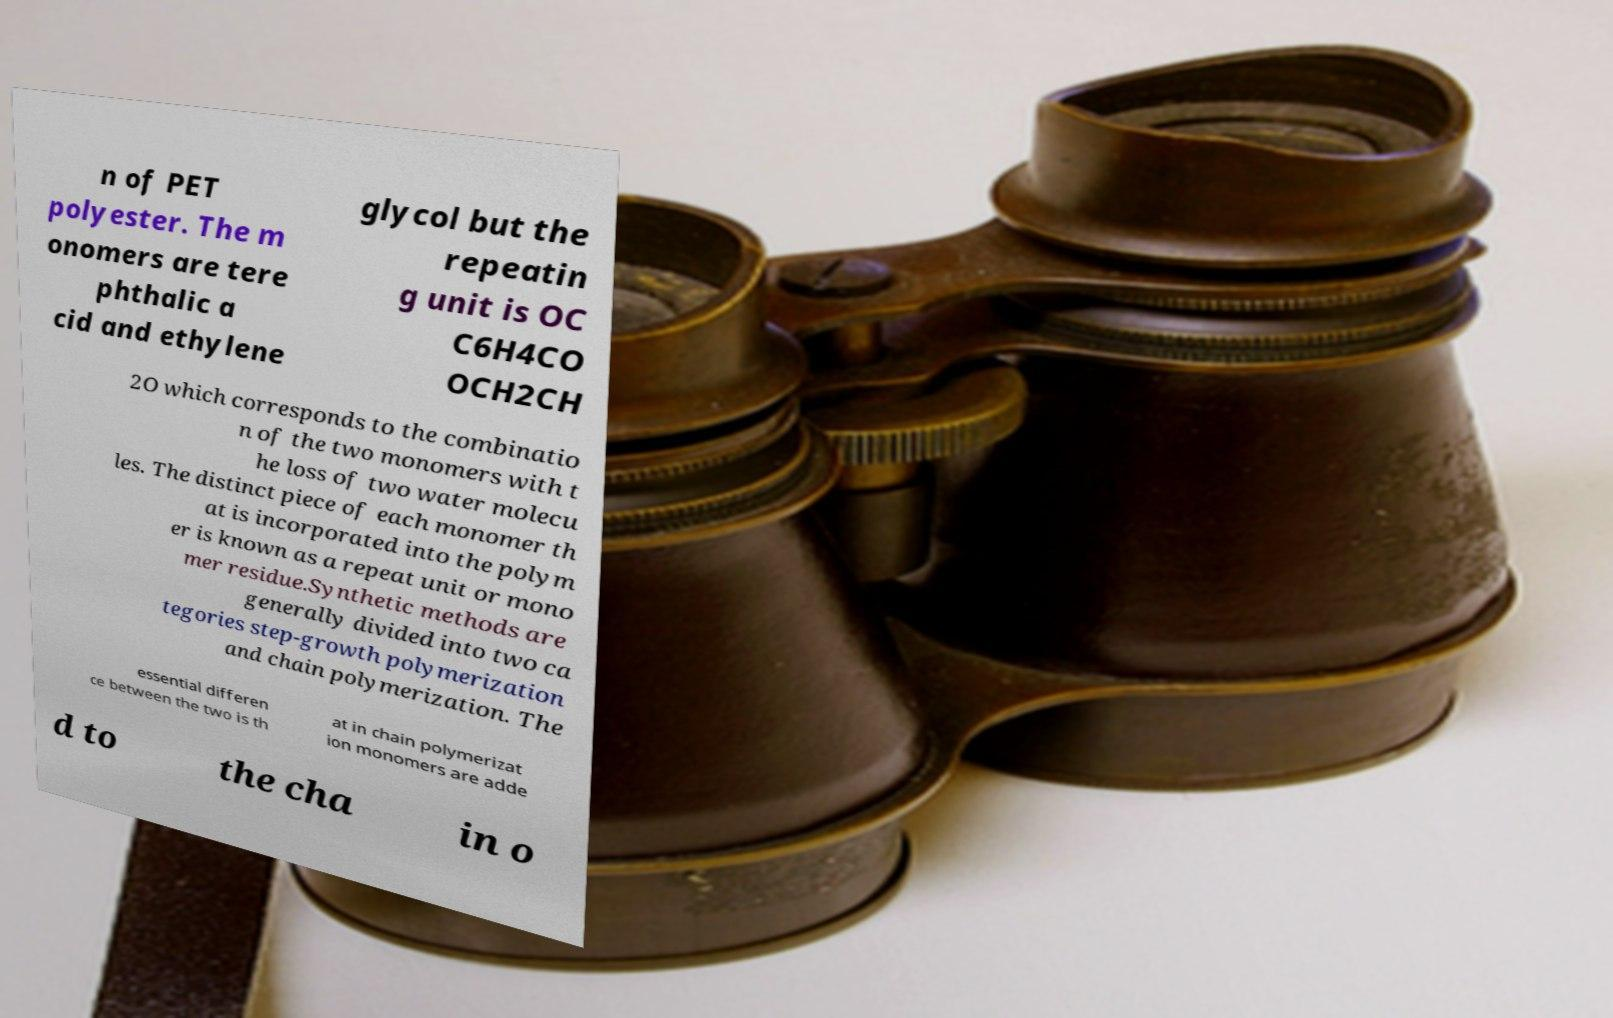What messages or text are displayed in this image? I need them in a readable, typed format. n of PET polyester. The m onomers are tere phthalic a cid and ethylene glycol but the repeatin g unit is OC C6H4CO OCH2CH 2O which corresponds to the combinatio n of the two monomers with t he loss of two water molecu les. The distinct piece of each monomer th at is incorporated into the polym er is known as a repeat unit or mono mer residue.Synthetic methods are generally divided into two ca tegories step-growth polymerization and chain polymerization. The essential differen ce between the two is th at in chain polymerizat ion monomers are adde d to the cha in o 